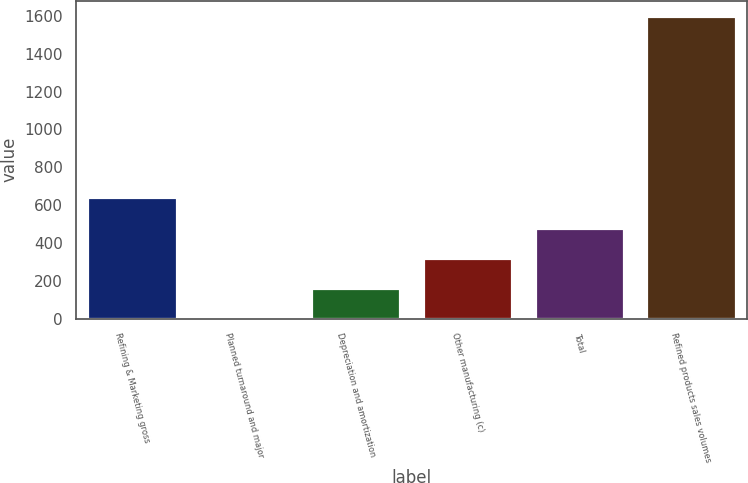<chart> <loc_0><loc_0><loc_500><loc_500><bar_chart><fcel>Refining & Marketing gross<fcel>Planned turnaround and major<fcel>Depreciation and amortization<fcel>Other manufacturing (c)<fcel>Total<fcel>Refined products sales volumes<nl><fcel>640.2<fcel>1<fcel>160.8<fcel>320.6<fcel>480.4<fcel>1599<nl></chart> 